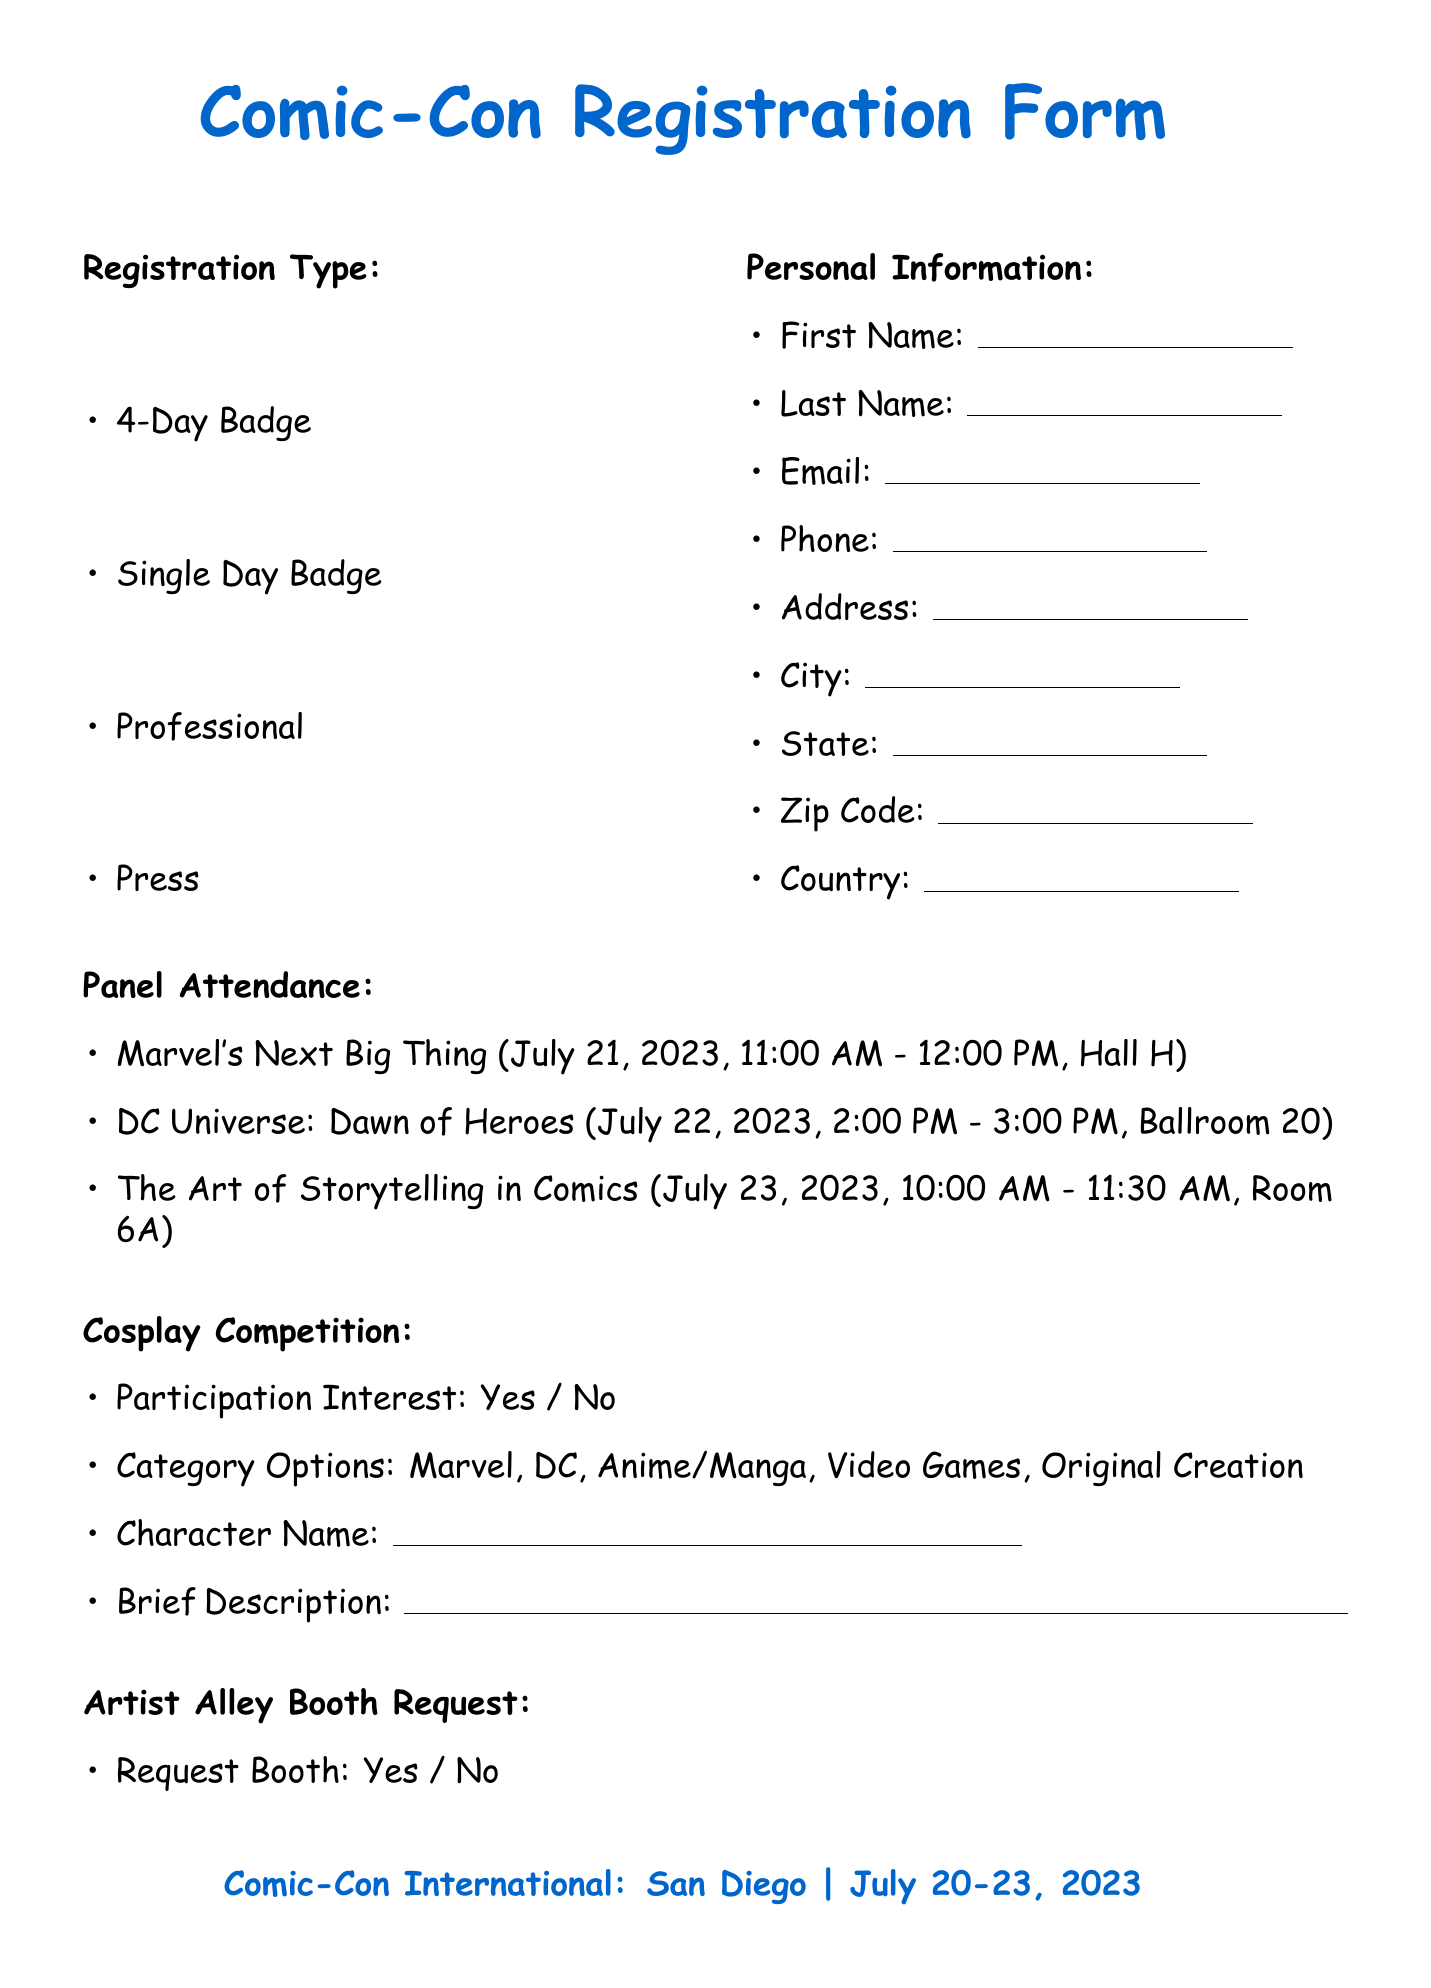what are the event dates? The event dates for Comic-Con International: San Diego are clearly mentioned in the document as July 20-23, 2023.
Answer: July 20-23, 2023 what type of badge is available for professional attendees? The document specifies that there is a registration type called "Professional" meant for industry professionals.
Answer: Professional what is the name of the first panel listed? The document lists three panels, with the first being "Marvel's Next Big Thing."
Answer: Marvel's Next Big Thing which category options are available for the cosplay competition? The document outlines several participation category options for the cosplay competition; they include Marvel, DC, Anime/Manga, Video Games, and Original Creation.
Answer: Marvel, DC, Anime/Manga, Video Games, Original Creation how long is the "Comic Script Writing Masterclass"? The duration of the workshop is explicitly stated in the document, lasting from 3:00 PM to 5:00 PM on July 21, 2023.
Answer: 2 hours if someone wants to order a T-shirt, how much will it cost? The document provides pricing information for the Exclusive Comic-Con 2023 T-Shirt, which is mentioned as $25.00.
Answer: $25.00 what is the primary genre options for artist alley booth requests? The document lists multiple primary genre options concerning artist alley booth requests, including Superhero, Indie Comics, Manga-style, and Webcomics.
Answer: Superhero, Indie Comics, Manga-style, Webcomics what must be included in the emergency contact section? The document explicitly requires the name, relationship, and phone number of the emergency contact person to be filled out.
Answer: Name, Relationship, Phone how many different card types are accepted for payment? The document specifies three card types: Visa, MasterCard, and American Express, indicating a total of three options.
Answer: 3 